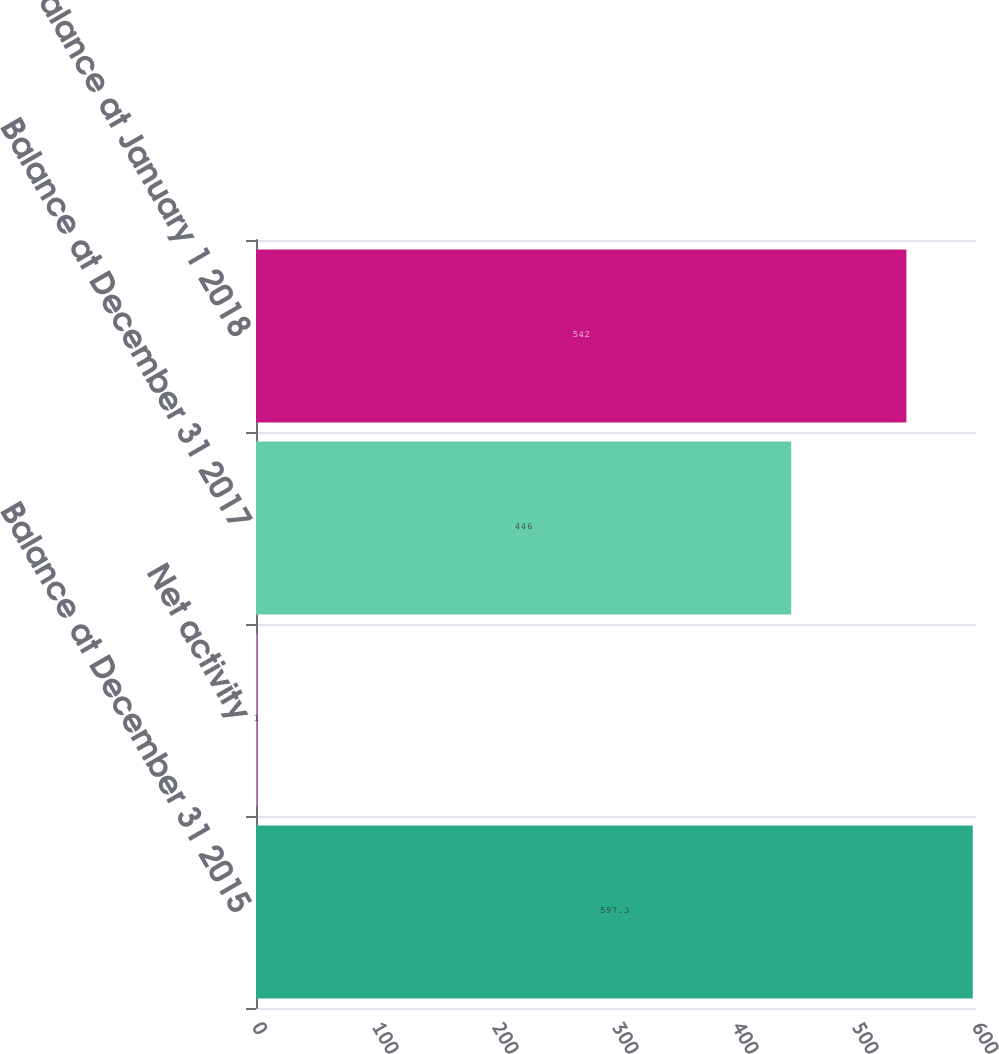Convert chart to OTSL. <chart><loc_0><loc_0><loc_500><loc_500><bar_chart><fcel>Balance at December 31 2015<fcel>Net activity<fcel>Balance at December 31 2017<fcel>Balance at January 1 2018<nl><fcel>597.3<fcel>1<fcel>446<fcel>542<nl></chart> 